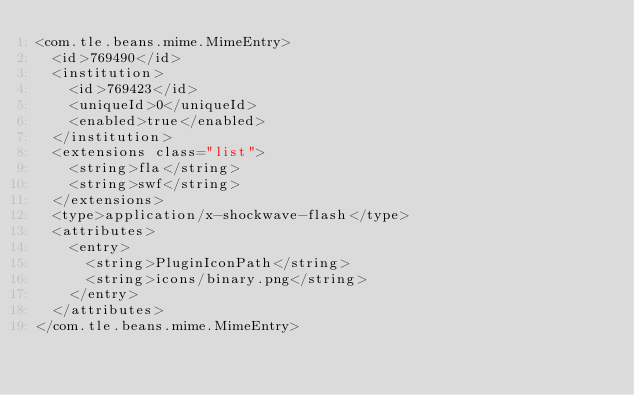<code> <loc_0><loc_0><loc_500><loc_500><_XML_><com.tle.beans.mime.MimeEntry>
  <id>769490</id>
  <institution>
    <id>769423</id>
    <uniqueId>0</uniqueId>
    <enabled>true</enabled>
  </institution>
  <extensions class="list">
    <string>fla</string>
    <string>swf</string>
  </extensions>
  <type>application/x-shockwave-flash</type>
  <attributes>
    <entry>
      <string>PluginIconPath</string>
      <string>icons/binary.png</string>
    </entry>
  </attributes>
</com.tle.beans.mime.MimeEntry></code> 